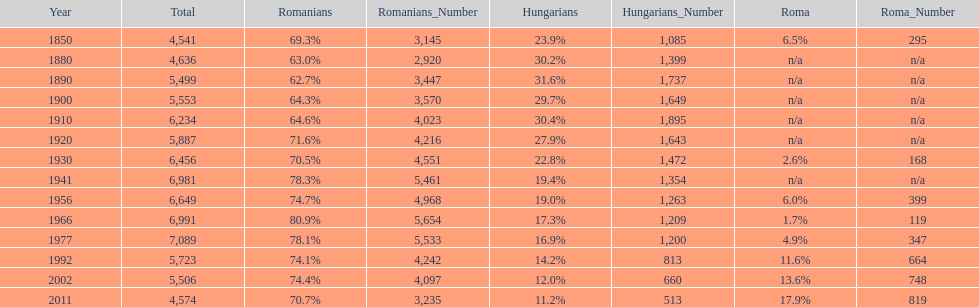What were the total number of times the romanians had a population percentage above 70%? 9. 